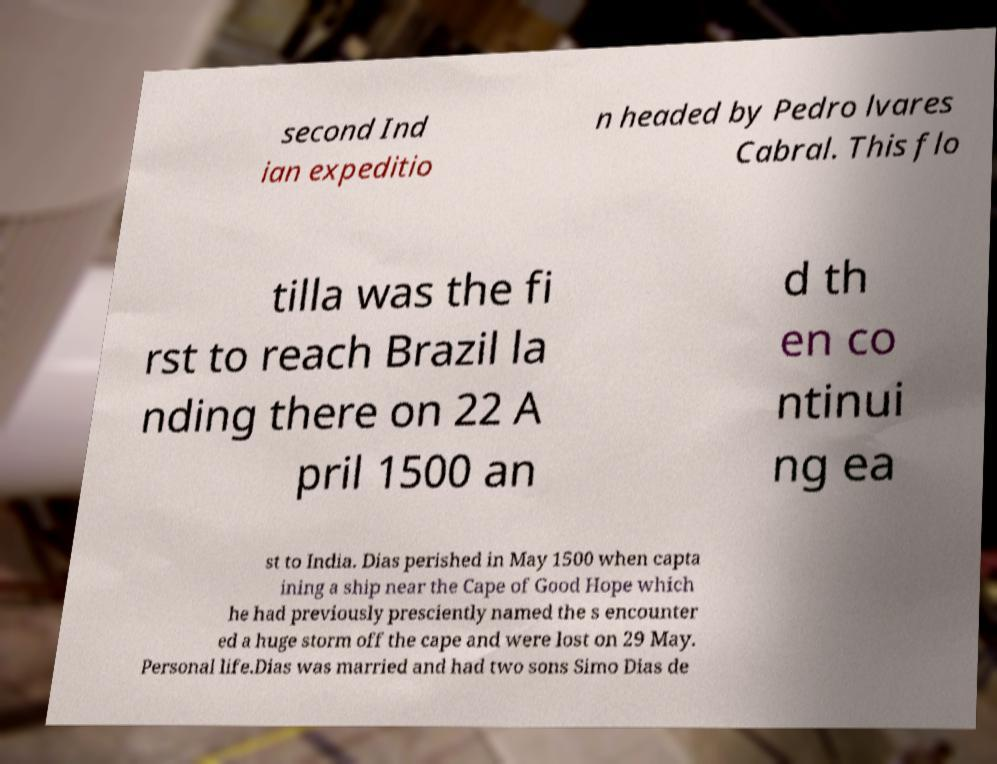There's text embedded in this image that I need extracted. Can you transcribe it verbatim? second Ind ian expeditio n headed by Pedro lvares Cabral. This flo tilla was the fi rst to reach Brazil la nding there on 22 A pril 1500 an d th en co ntinui ng ea st to India. Dias perished in May 1500 when capta ining a ship near the Cape of Good Hope which he had previously presciently named the s encounter ed a huge storm off the cape and were lost on 29 May. Personal life.Dias was married and had two sons Simo Dias de 